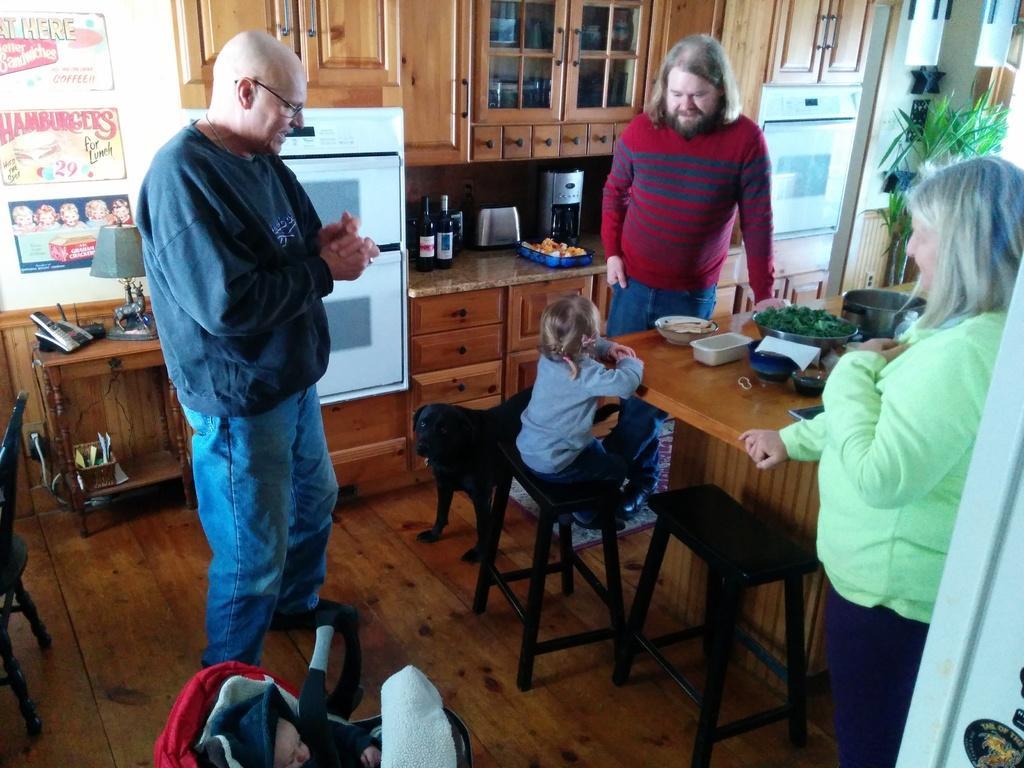In one or two sentences, can you explain what this image depicts? There are two men and one woman staring at a small kid, who is sitting on the stool. here is a black dog standing beside a small girl. I can see two beer bottles and a coffee machine placed on the marble stone. And these are the cupboards where things can be stored. And i can see a house plant at the right corner of the image. And this is a table where bowls are placed on it. And I can see a stroller at the bottom of the image,In this stroller there is a baby sleeping. And I can see a chair at the left corner of the image. And here is the telephone and there is a lamp beside the telephone. 